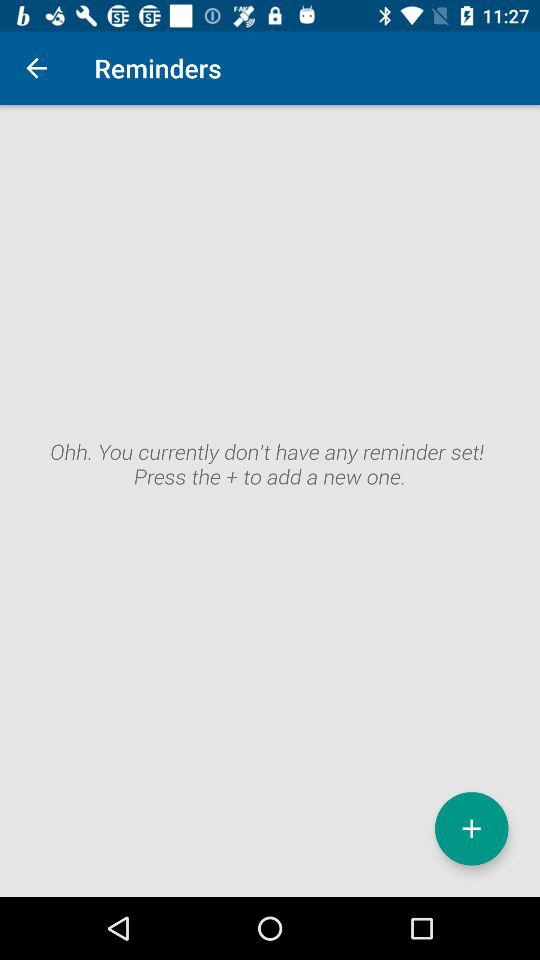Do we have any reminders set? You don't have any reminders set. 